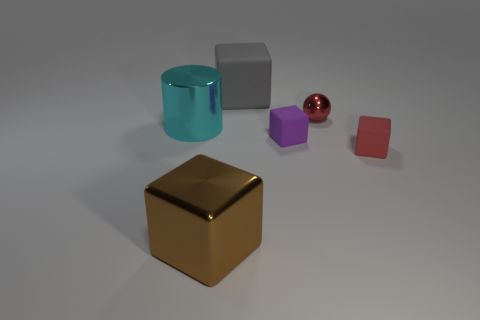How many other objects are the same color as the tiny shiny thing?
Your answer should be compact. 1. What material is the object that is the same color as the tiny metallic sphere?
Ensure brevity in your answer.  Rubber. How many large things are blue things or red rubber cubes?
Keep it short and to the point. 0. Are there an equal number of red shiny spheres left of the big shiny cylinder and brown metal objects?
Provide a short and direct response. No. Are there any big brown objects in front of the large brown metal object?
Your answer should be compact. No. How many rubber objects are either cyan objects or purple blocks?
Make the answer very short. 1. There is a big brown metal object; what number of big cyan things are left of it?
Your response must be concise. 1. Are there any gray objects of the same size as the red sphere?
Offer a terse response. No. Are there any cylinders that have the same color as the tiny metallic sphere?
Your response must be concise. No. Are there any other things that are the same size as the purple rubber cube?
Provide a short and direct response. Yes. 